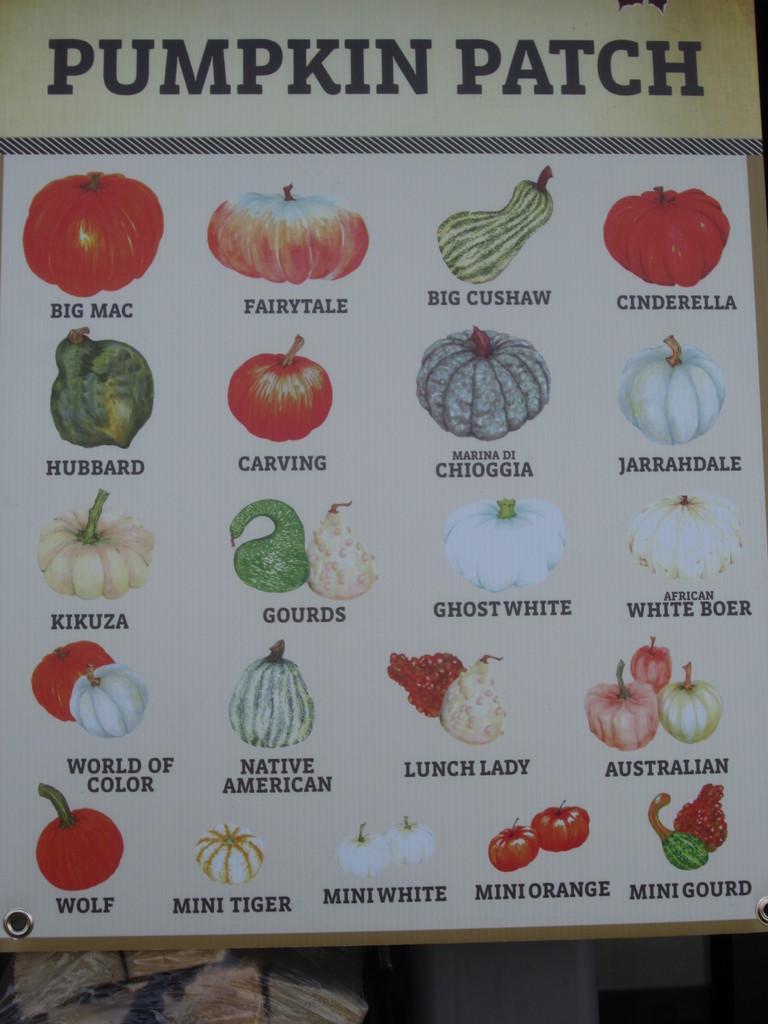How would you summarize this image in a sentence or two? In this image there is a poster with pictures of fruits and vegetables. At the bottom of the image there are few objects. 